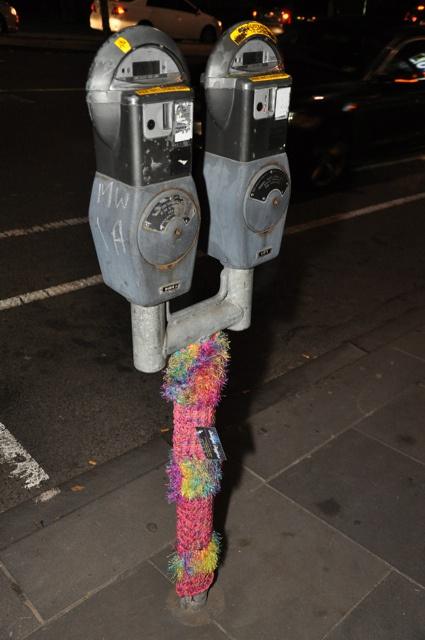Describe the objects in this image and their specific colors. I can see parking meter in black, gray, and darkgray tones, parking meter in black and gray tones, car in black, maroon, gray, and red tones, car in black, maroon, brown, and tan tones, and car in black, maroon, brown, and red tones in this image. 